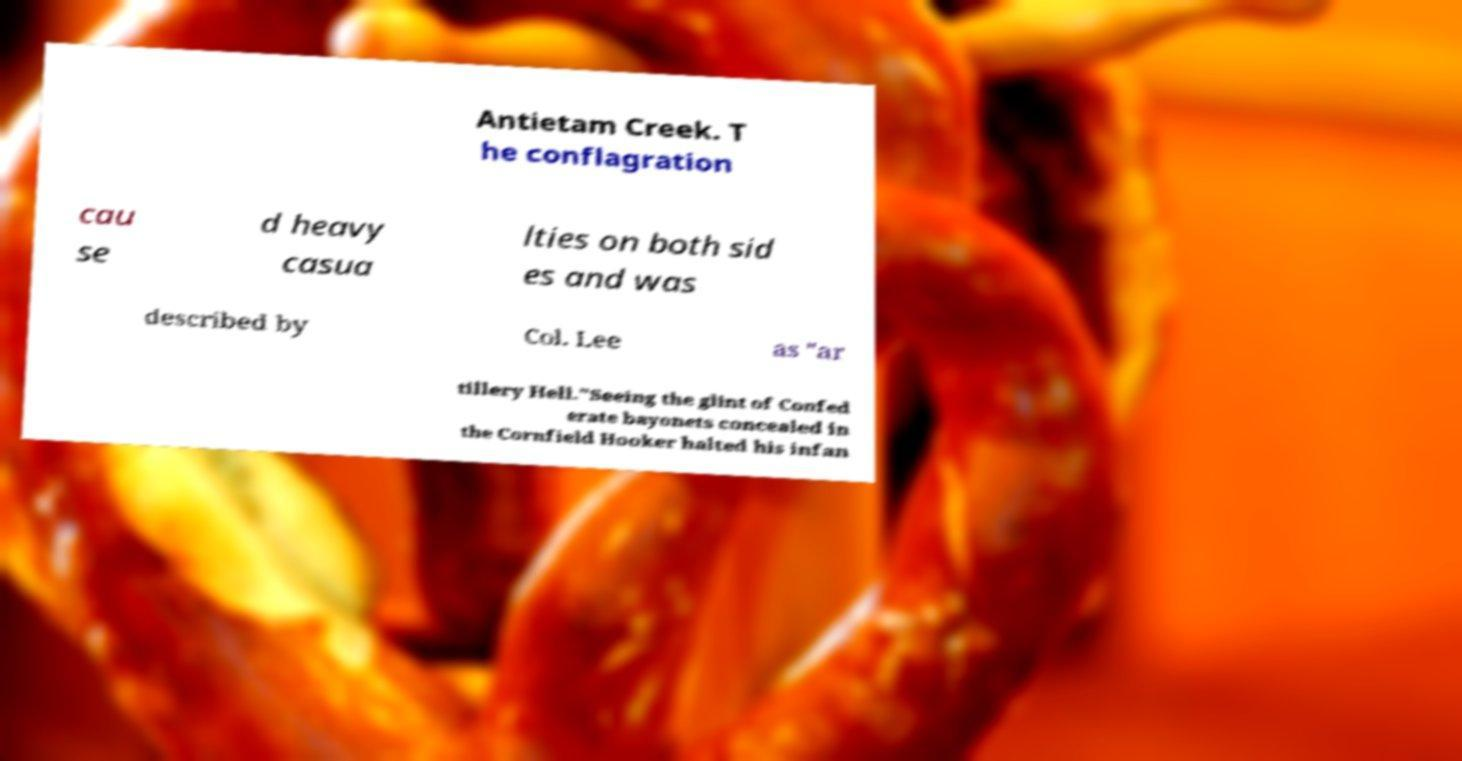Can you read and provide the text displayed in the image?This photo seems to have some interesting text. Can you extract and type it out for me? Antietam Creek. T he conflagration cau se d heavy casua lties on both sid es and was described by Col. Lee as "ar tillery Hell."Seeing the glint of Confed erate bayonets concealed in the Cornfield Hooker halted his infan 